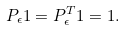Convert formula to latex. <formula><loc_0><loc_0><loc_500><loc_500>P _ { \epsilon } 1 = P _ { \epsilon } ^ { T } 1 = 1 .</formula> 